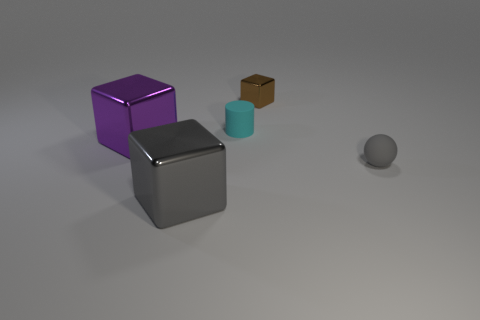How many other things are there of the same size as the rubber cylinder?
Keep it short and to the point. 2. What number of things are either large yellow rubber cubes or metal blocks behind the gray rubber thing?
Provide a short and direct response. 2. Is the number of gray rubber objects left of the cyan matte cylinder the same as the number of tiny purple cubes?
Your answer should be very brief. Yes. The brown thing that is the same material as the big gray thing is what shape?
Provide a short and direct response. Cube. Are there any rubber spheres of the same color as the tiny shiny block?
Provide a succinct answer. No. How many shiny things are gray blocks or tiny purple cylinders?
Provide a short and direct response. 1. How many gray rubber spheres are behind the rubber object that is to the right of the brown shiny block?
Offer a very short reply. 0. How many small things are the same material as the tiny gray ball?
Ensure brevity in your answer.  1. What number of tiny things are either purple matte cubes or brown cubes?
Keep it short and to the point. 1. There is a object that is in front of the big purple shiny block and to the left of the small sphere; what shape is it?
Provide a succinct answer. Cube. 